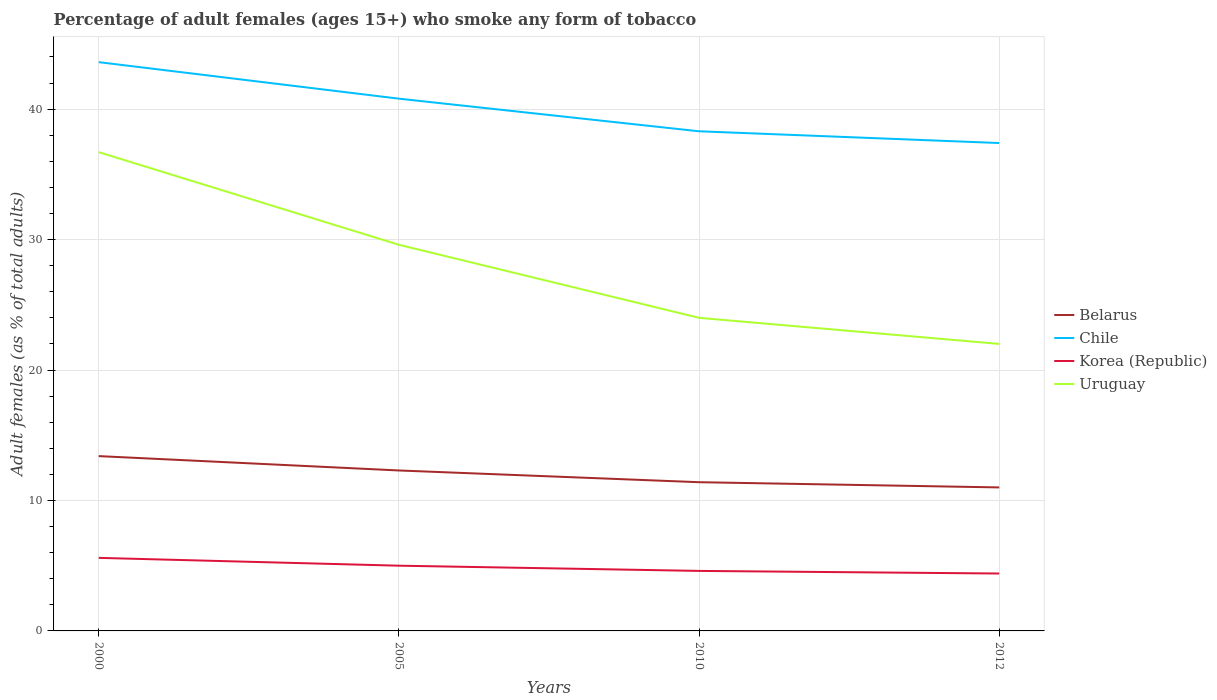How many different coloured lines are there?
Your answer should be very brief. 4. Does the line corresponding to Korea (Republic) intersect with the line corresponding to Chile?
Keep it short and to the point. No. Across all years, what is the maximum percentage of adult females who smoke in Chile?
Give a very brief answer. 37.4. What is the total percentage of adult females who smoke in Korea (Republic) in the graph?
Offer a terse response. 0.2. What is the difference between the highest and the second highest percentage of adult females who smoke in Uruguay?
Give a very brief answer. 14.7. How many years are there in the graph?
Your answer should be very brief. 4. What is the difference between two consecutive major ticks on the Y-axis?
Make the answer very short. 10. Does the graph contain grids?
Make the answer very short. Yes. How many legend labels are there?
Your answer should be compact. 4. How are the legend labels stacked?
Your response must be concise. Vertical. What is the title of the graph?
Provide a short and direct response. Percentage of adult females (ages 15+) who smoke any form of tobacco. What is the label or title of the Y-axis?
Your answer should be very brief. Adult females (as % of total adults). What is the Adult females (as % of total adults) of Chile in 2000?
Keep it short and to the point. 43.6. What is the Adult females (as % of total adults) in Uruguay in 2000?
Your response must be concise. 36.7. What is the Adult females (as % of total adults) of Belarus in 2005?
Give a very brief answer. 12.3. What is the Adult females (as % of total adults) in Chile in 2005?
Your response must be concise. 40.8. What is the Adult females (as % of total adults) of Uruguay in 2005?
Provide a succinct answer. 29.6. What is the Adult females (as % of total adults) of Chile in 2010?
Your answer should be very brief. 38.3. What is the Adult females (as % of total adults) of Korea (Republic) in 2010?
Offer a very short reply. 4.6. What is the Adult females (as % of total adults) of Chile in 2012?
Offer a terse response. 37.4. What is the Adult females (as % of total adults) of Uruguay in 2012?
Your answer should be compact. 22. Across all years, what is the maximum Adult females (as % of total adults) in Chile?
Your response must be concise. 43.6. Across all years, what is the maximum Adult females (as % of total adults) of Korea (Republic)?
Make the answer very short. 5.6. Across all years, what is the maximum Adult females (as % of total adults) in Uruguay?
Ensure brevity in your answer.  36.7. Across all years, what is the minimum Adult females (as % of total adults) of Chile?
Offer a very short reply. 37.4. Across all years, what is the minimum Adult females (as % of total adults) of Uruguay?
Offer a terse response. 22. What is the total Adult females (as % of total adults) in Belarus in the graph?
Your response must be concise. 48.1. What is the total Adult females (as % of total adults) in Chile in the graph?
Ensure brevity in your answer.  160.1. What is the total Adult females (as % of total adults) in Korea (Republic) in the graph?
Offer a terse response. 19.6. What is the total Adult females (as % of total adults) of Uruguay in the graph?
Your answer should be very brief. 112.3. What is the difference between the Adult females (as % of total adults) of Chile in 2000 and that in 2005?
Offer a terse response. 2.8. What is the difference between the Adult females (as % of total adults) in Korea (Republic) in 2000 and that in 2005?
Your answer should be very brief. 0.6. What is the difference between the Adult females (as % of total adults) in Uruguay in 2000 and that in 2005?
Offer a very short reply. 7.1. What is the difference between the Adult females (as % of total adults) of Uruguay in 2000 and that in 2010?
Provide a short and direct response. 12.7. What is the difference between the Adult females (as % of total adults) in Chile in 2000 and that in 2012?
Give a very brief answer. 6.2. What is the difference between the Adult females (as % of total adults) in Uruguay in 2000 and that in 2012?
Offer a very short reply. 14.7. What is the difference between the Adult females (as % of total adults) in Belarus in 2005 and that in 2010?
Give a very brief answer. 0.9. What is the difference between the Adult females (as % of total adults) of Chile in 2005 and that in 2010?
Offer a terse response. 2.5. What is the difference between the Adult females (as % of total adults) of Chile in 2005 and that in 2012?
Your response must be concise. 3.4. What is the difference between the Adult females (as % of total adults) of Korea (Republic) in 2010 and that in 2012?
Ensure brevity in your answer.  0.2. What is the difference between the Adult females (as % of total adults) in Uruguay in 2010 and that in 2012?
Keep it short and to the point. 2. What is the difference between the Adult females (as % of total adults) of Belarus in 2000 and the Adult females (as % of total adults) of Chile in 2005?
Your answer should be very brief. -27.4. What is the difference between the Adult females (as % of total adults) of Belarus in 2000 and the Adult females (as % of total adults) of Uruguay in 2005?
Your answer should be very brief. -16.2. What is the difference between the Adult females (as % of total adults) in Chile in 2000 and the Adult females (as % of total adults) in Korea (Republic) in 2005?
Your answer should be compact. 38.6. What is the difference between the Adult females (as % of total adults) of Chile in 2000 and the Adult females (as % of total adults) of Uruguay in 2005?
Provide a short and direct response. 14. What is the difference between the Adult females (as % of total adults) of Korea (Republic) in 2000 and the Adult females (as % of total adults) of Uruguay in 2005?
Your answer should be compact. -24. What is the difference between the Adult females (as % of total adults) of Belarus in 2000 and the Adult females (as % of total adults) of Chile in 2010?
Provide a succinct answer. -24.9. What is the difference between the Adult females (as % of total adults) in Chile in 2000 and the Adult females (as % of total adults) in Korea (Republic) in 2010?
Give a very brief answer. 39. What is the difference between the Adult females (as % of total adults) of Chile in 2000 and the Adult females (as % of total adults) of Uruguay in 2010?
Your response must be concise. 19.6. What is the difference between the Adult females (as % of total adults) in Korea (Republic) in 2000 and the Adult females (as % of total adults) in Uruguay in 2010?
Provide a short and direct response. -18.4. What is the difference between the Adult females (as % of total adults) in Belarus in 2000 and the Adult females (as % of total adults) in Uruguay in 2012?
Give a very brief answer. -8.6. What is the difference between the Adult females (as % of total adults) of Chile in 2000 and the Adult females (as % of total adults) of Korea (Republic) in 2012?
Give a very brief answer. 39.2. What is the difference between the Adult females (as % of total adults) in Chile in 2000 and the Adult females (as % of total adults) in Uruguay in 2012?
Provide a succinct answer. 21.6. What is the difference between the Adult females (as % of total adults) of Korea (Republic) in 2000 and the Adult females (as % of total adults) of Uruguay in 2012?
Keep it short and to the point. -16.4. What is the difference between the Adult females (as % of total adults) in Belarus in 2005 and the Adult females (as % of total adults) in Uruguay in 2010?
Keep it short and to the point. -11.7. What is the difference between the Adult females (as % of total adults) in Chile in 2005 and the Adult females (as % of total adults) in Korea (Republic) in 2010?
Your response must be concise. 36.2. What is the difference between the Adult females (as % of total adults) in Korea (Republic) in 2005 and the Adult females (as % of total adults) in Uruguay in 2010?
Offer a terse response. -19. What is the difference between the Adult females (as % of total adults) in Belarus in 2005 and the Adult females (as % of total adults) in Chile in 2012?
Your answer should be compact. -25.1. What is the difference between the Adult females (as % of total adults) of Belarus in 2005 and the Adult females (as % of total adults) of Korea (Republic) in 2012?
Make the answer very short. 7.9. What is the difference between the Adult females (as % of total adults) of Belarus in 2005 and the Adult females (as % of total adults) of Uruguay in 2012?
Give a very brief answer. -9.7. What is the difference between the Adult females (as % of total adults) in Chile in 2005 and the Adult females (as % of total adults) in Korea (Republic) in 2012?
Offer a terse response. 36.4. What is the difference between the Adult females (as % of total adults) of Chile in 2010 and the Adult females (as % of total adults) of Korea (Republic) in 2012?
Your answer should be compact. 33.9. What is the difference between the Adult females (as % of total adults) of Chile in 2010 and the Adult females (as % of total adults) of Uruguay in 2012?
Provide a short and direct response. 16.3. What is the difference between the Adult females (as % of total adults) in Korea (Republic) in 2010 and the Adult females (as % of total adults) in Uruguay in 2012?
Provide a short and direct response. -17.4. What is the average Adult females (as % of total adults) of Belarus per year?
Your answer should be very brief. 12.03. What is the average Adult females (as % of total adults) of Chile per year?
Your answer should be very brief. 40.02. What is the average Adult females (as % of total adults) in Uruguay per year?
Make the answer very short. 28.07. In the year 2000, what is the difference between the Adult females (as % of total adults) in Belarus and Adult females (as % of total adults) in Chile?
Keep it short and to the point. -30.2. In the year 2000, what is the difference between the Adult females (as % of total adults) of Belarus and Adult females (as % of total adults) of Korea (Republic)?
Make the answer very short. 7.8. In the year 2000, what is the difference between the Adult females (as % of total adults) of Belarus and Adult females (as % of total adults) of Uruguay?
Ensure brevity in your answer.  -23.3. In the year 2000, what is the difference between the Adult females (as % of total adults) in Korea (Republic) and Adult females (as % of total adults) in Uruguay?
Give a very brief answer. -31.1. In the year 2005, what is the difference between the Adult females (as % of total adults) of Belarus and Adult females (as % of total adults) of Chile?
Provide a short and direct response. -28.5. In the year 2005, what is the difference between the Adult females (as % of total adults) in Belarus and Adult females (as % of total adults) in Korea (Republic)?
Your answer should be very brief. 7.3. In the year 2005, what is the difference between the Adult females (as % of total adults) in Belarus and Adult females (as % of total adults) in Uruguay?
Provide a short and direct response. -17.3. In the year 2005, what is the difference between the Adult females (as % of total adults) of Chile and Adult females (as % of total adults) of Korea (Republic)?
Offer a very short reply. 35.8. In the year 2005, what is the difference between the Adult females (as % of total adults) in Chile and Adult females (as % of total adults) in Uruguay?
Keep it short and to the point. 11.2. In the year 2005, what is the difference between the Adult females (as % of total adults) of Korea (Republic) and Adult females (as % of total adults) of Uruguay?
Your answer should be very brief. -24.6. In the year 2010, what is the difference between the Adult females (as % of total adults) of Belarus and Adult females (as % of total adults) of Chile?
Your response must be concise. -26.9. In the year 2010, what is the difference between the Adult females (as % of total adults) in Belarus and Adult females (as % of total adults) in Korea (Republic)?
Provide a succinct answer. 6.8. In the year 2010, what is the difference between the Adult females (as % of total adults) of Chile and Adult females (as % of total adults) of Korea (Republic)?
Keep it short and to the point. 33.7. In the year 2010, what is the difference between the Adult females (as % of total adults) of Korea (Republic) and Adult females (as % of total adults) of Uruguay?
Offer a terse response. -19.4. In the year 2012, what is the difference between the Adult females (as % of total adults) of Belarus and Adult females (as % of total adults) of Chile?
Give a very brief answer. -26.4. In the year 2012, what is the difference between the Adult females (as % of total adults) in Belarus and Adult females (as % of total adults) in Korea (Republic)?
Your response must be concise. 6.6. In the year 2012, what is the difference between the Adult females (as % of total adults) of Korea (Republic) and Adult females (as % of total adults) of Uruguay?
Offer a terse response. -17.6. What is the ratio of the Adult females (as % of total adults) in Belarus in 2000 to that in 2005?
Give a very brief answer. 1.09. What is the ratio of the Adult females (as % of total adults) in Chile in 2000 to that in 2005?
Provide a short and direct response. 1.07. What is the ratio of the Adult females (as % of total adults) in Korea (Republic) in 2000 to that in 2005?
Keep it short and to the point. 1.12. What is the ratio of the Adult females (as % of total adults) in Uruguay in 2000 to that in 2005?
Give a very brief answer. 1.24. What is the ratio of the Adult females (as % of total adults) of Belarus in 2000 to that in 2010?
Your answer should be compact. 1.18. What is the ratio of the Adult females (as % of total adults) in Chile in 2000 to that in 2010?
Keep it short and to the point. 1.14. What is the ratio of the Adult females (as % of total adults) of Korea (Republic) in 2000 to that in 2010?
Keep it short and to the point. 1.22. What is the ratio of the Adult females (as % of total adults) in Uruguay in 2000 to that in 2010?
Ensure brevity in your answer.  1.53. What is the ratio of the Adult females (as % of total adults) in Belarus in 2000 to that in 2012?
Offer a very short reply. 1.22. What is the ratio of the Adult females (as % of total adults) in Chile in 2000 to that in 2012?
Offer a terse response. 1.17. What is the ratio of the Adult females (as % of total adults) in Korea (Republic) in 2000 to that in 2012?
Offer a terse response. 1.27. What is the ratio of the Adult females (as % of total adults) of Uruguay in 2000 to that in 2012?
Offer a very short reply. 1.67. What is the ratio of the Adult females (as % of total adults) of Belarus in 2005 to that in 2010?
Make the answer very short. 1.08. What is the ratio of the Adult females (as % of total adults) in Chile in 2005 to that in 2010?
Make the answer very short. 1.07. What is the ratio of the Adult females (as % of total adults) of Korea (Republic) in 2005 to that in 2010?
Your answer should be compact. 1.09. What is the ratio of the Adult females (as % of total adults) of Uruguay in 2005 to that in 2010?
Keep it short and to the point. 1.23. What is the ratio of the Adult females (as % of total adults) in Belarus in 2005 to that in 2012?
Provide a succinct answer. 1.12. What is the ratio of the Adult females (as % of total adults) in Korea (Republic) in 2005 to that in 2012?
Provide a short and direct response. 1.14. What is the ratio of the Adult females (as % of total adults) in Uruguay in 2005 to that in 2012?
Your answer should be compact. 1.35. What is the ratio of the Adult females (as % of total adults) of Belarus in 2010 to that in 2012?
Provide a succinct answer. 1.04. What is the ratio of the Adult females (as % of total adults) of Chile in 2010 to that in 2012?
Keep it short and to the point. 1.02. What is the ratio of the Adult females (as % of total adults) of Korea (Republic) in 2010 to that in 2012?
Offer a terse response. 1.05. What is the difference between the highest and the second highest Adult females (as % of total adults) in Chile?
Ensure brevity in your answer.  2.8. What is the difference between the highest and the second highest Adult females (as % of total adults) in Korea (Republic)?
Provide a short and direct response. 0.6. What is the difference between the highest and the second highest Adult females (as % of total adults) in Uruguay?
Offer a very short reply. 7.1. What is the difference between the highest and the lowest Adult females (as % of total adults) of Korea (Republic)?
Ensure brevity in your answer.  1.2. 